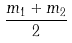Convert formula to latex. <formula><loc_0><loc_0><loc_500><loc_500>\frac { m _ { 1 } + m _ { 2 } } { 2 }</formula> 